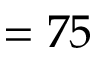<formula> <loc_0><loc_0><loc_500><loc_500>= 7 5</formula> 